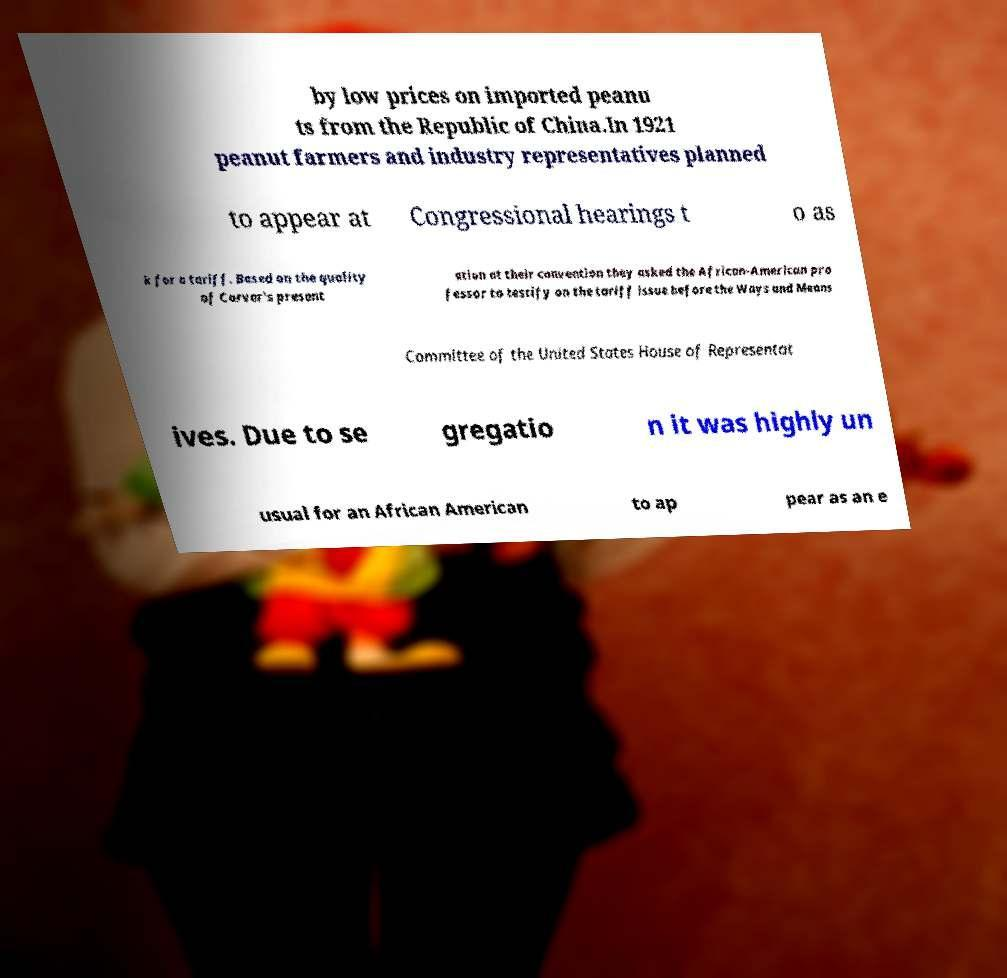Could you assist in decoding the text presented in this image and type it out clearly? by low prices on imported peanu ts from the Republic of China.In 1921 peanut farmers and industry representatives planned to appear at Congressional hearings t o as k for a tariff. Based on the quality of Carver's present ation at their convention they asked the African-American pro fessor to testify on the tariff issue before the Ways and Means Committee of the United States House of Representat ives. Due to se gregatio n it was highly un usual for an African American to ap pear as an e 